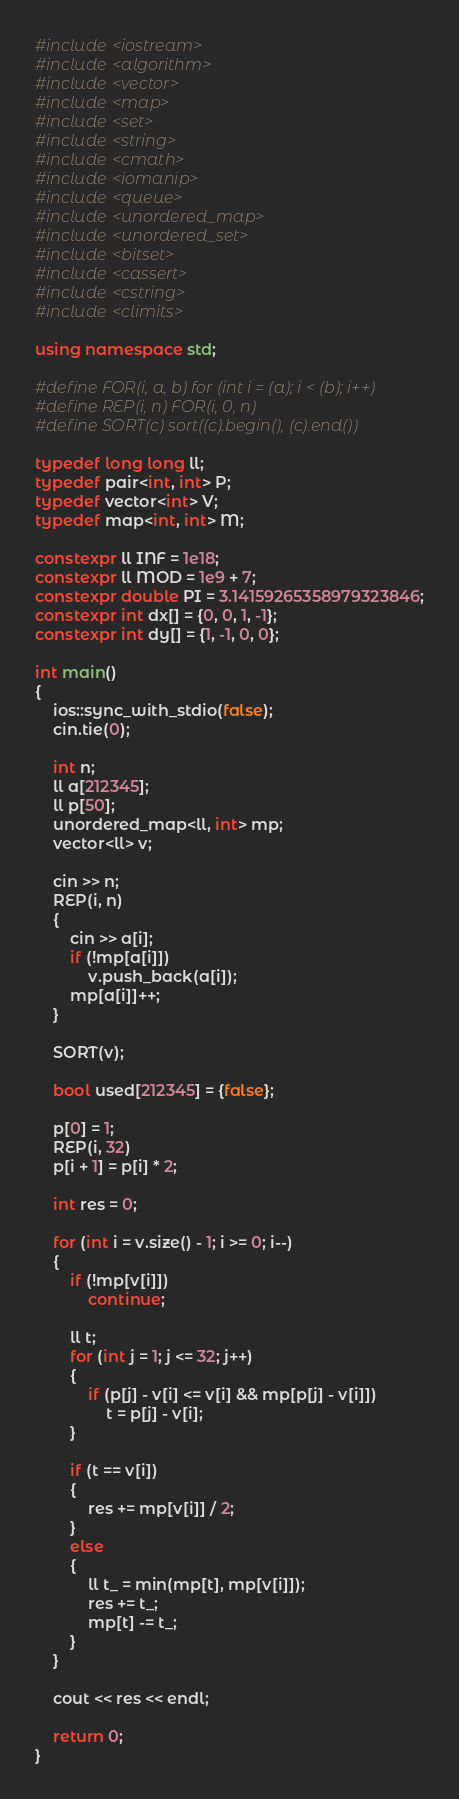<code> <loc_0><loc_0><loc_500><loc_500><_C++_>#include <iostream>
#include <algorithm>
#include <vector>
#include <map>
#include <set>
#include <string>
#include <cmath>
#include <iomanip>
#include <queue>
#include <unordered_map>
#include <unordered_set>
#include <bitset>
#include <cassert>
#include <cstring>
#include <climits>

using namespace std;

#define FOR(i, a, b) for (int i = (a); i < (b); i++)
#define REP(i, n) FOR(i, 0, n)
#define SORT(c) sort((c).begin(), (c).end())

typedef long long ll;
typedef pair<int, int> P;
typedef vector<int> V;
typedef map<int, int> M;

constexpr ll INF = 1e18;
constexpr ll MOD = 1e9 + 7;
constexpr double PI = 3.14159265358979323846;
constexpr int dx[] = {0, 0, 1, -1};
constexpr int dy[] = {1, -1, 0, 0};

int main()
{
    ios::sync_with_stdio(false);
    cin.tie(0);

    int n;
    ll a[212345];
    ll p[50];
    unordered_map<ll, int> mp;
    vector<ll> v;

    cin >> n;
    REP(i, n)
    {
        cin >> a[i];
        if (!mp[a[i]])
            v.push_back(a[i]);
        mp[a[i]]++;
    }

    SORT(v);

    bool used[212345] = {false};

    p[0] = 1;
    REP(i, 32)
    p[i + 1] = p[i] * 2;

    int res = 0;

    for (int i = v.size() - 1; i >= 0; i--)
    {
        if (!mp[v[i]])
            continue;

        ll t;
        for (int j = 1; j <= 32; j++)
        {
            if (p[j] - v[i] <= v[i] && mp[p[j] - v[i]])
                t = p[j] - v[i];
        }

        if (t == v[i])
        {
            res += mp[v[i]] / 2;
        }
        else
        {
            ll t_ = min(mp[t], mp[v[i]]);
            res += t_;
            mp[t] -= t_;
        }
    }

    cout << res << endl;

    return 0;
}</code> 